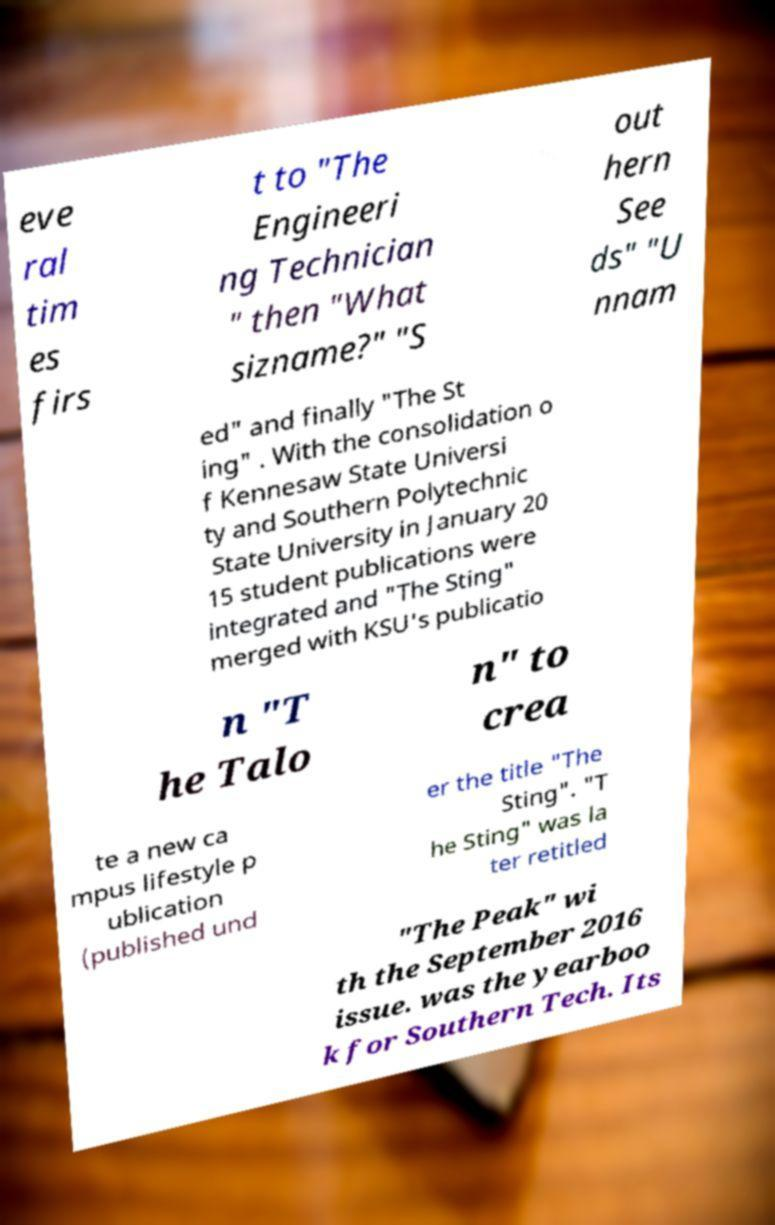What messages or text are displayed in this image? I need them in a readable, typed format. eve ral tim es firs t to "The Engineeri ng Technician " then "What sizname?" "S out hern See ds" "U nnam ed" and finally "The St ing" . With the consolidation o f Kennesaw State Universi ty and Southern Polytechnic State University in January 20 15 student publications were integrated and "The Sting" merged with KSU's publicatio n "T he Talo n" to crea te a new ca mpus lifestyle p ublication (published und er the title "The Sting". "T he Sting" was la ter retitled "The Peak" wi th the September 2016 issue. was the yearboo k for Southern Tech. Its 